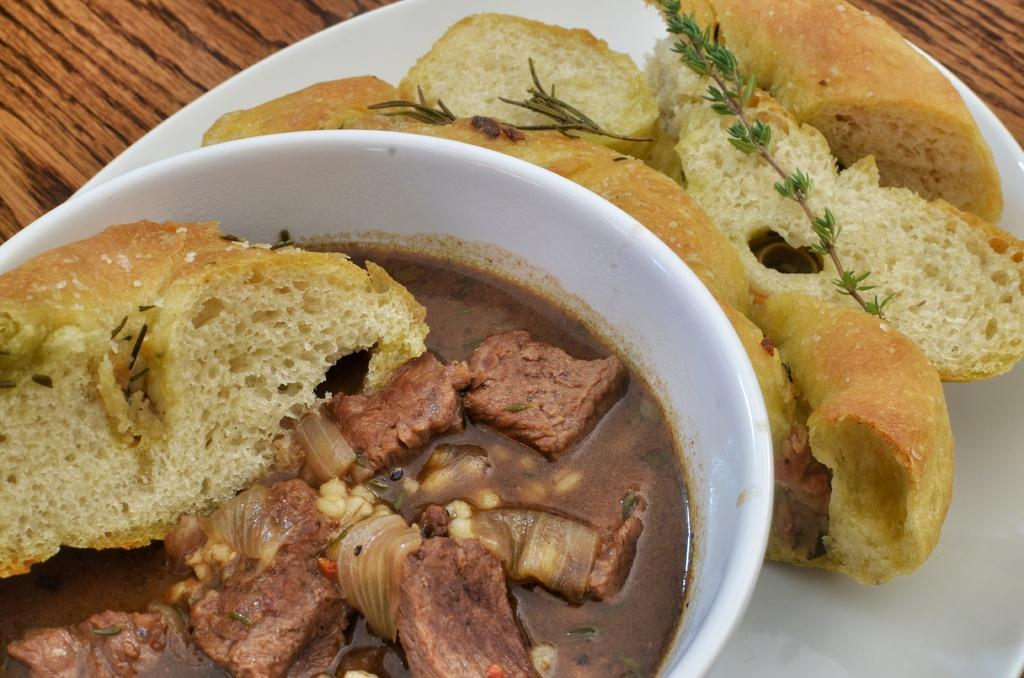What is located in the center of the image? There is a plate in the center of the image. What can be found in the bowl in the image? There is a bowl containing food in the image. What type of food is on the table in the image? There are breads placed on the table in the image. What type of patch can be seen on the road in the image? There is no road or patch present in the image; it only features a plate, a bowl containing food, and breads on the table. How many quivers are visible in the image? There are no quivers present in the image. 